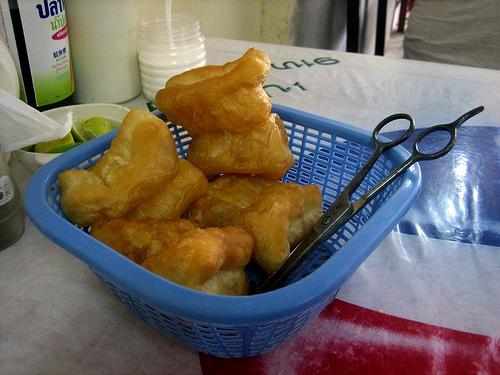Evaluate and describe the quality of the fried doughnuts in the basket. The fried doughnuts in the basket appear to be golden brown and irregular in shape, indicating they may be homemade and freshly cooked. How many distinct objects are visible on the table? There are eight distinct objects on the table: kitchen scissors, blue basket, fried doughnuts, lime wedges in a bowl, table cloth, vanilla extract, cream, and white cloth with green writing. Briefly describe the beverage in the image. There isn't any beverage in the image, but there is a bottle of cream and a bottle of vanilla extract. What are the unique features of the scissors present in the image? The scissors are silver, metal, possess holes in the handle for fingers, and have a screw or bolt on their side, enabling it to function as a pair. Is there any presence of citrus fruit in the image? If so, provide the details of the fruit and where it is placed. Yes, there are some lime wedges in a small white bowl on the table. Mention the colors present on the tablecloth and describe its material. The tablecloth features red, white, and blue colors and is made of plastic material. Determine the color and shape of the symbol on the tablecloth. The symbol on the tablecloth is red, white, and blue in color and is circular in shape. Analyze and explain the interaction between objects in the blue plastic basket. The metal scissors and fried doughnuts are placed together in the blue plastic basket, indicating a possible connection between cutting and serving the food. What type of food is in the blue basket along with the scissors? There are several irregular fried doughnuts in the blue plastic basket. Identify the kitchen utensil located in the basket. A pair of kitchen scissors are situated in the blue plastic basket. Is there any person or animal visible in the image? No, there are no people or animals. List the objects that can be found in the blue plastic basket. kitchen scissors, fried dough According to the text in the image, what is the color of the writing on the white table cloth? green What type of emotion can you infer from the arrangement of objects in the image? No emotions can be inferred from the objects. Do you see the green potted plant placed next to the bowl of lime wedges? A beautiful green plant in a ceramic pot is situated beside the white bowl containing lime wedges. In the context of cooking, discern the main event that the objects in the image suggest. preparing ingredients or serving a meal Identify the event related to food preparation that is represented by the objects in this image. cutting or serving fried dough Where is the open book with a blue bookmark laying on the table underneath the tablecloth? You will find an open book with a story about a magical land, and a vibrant blue bookmark is placed between the pages, partially covered by the tablecloth. Could you point out the steaming cup of coffee located on the table near the pair of scissors? There's a hot cup of coffee beside the kitchen scissors, and you can see the steam rising from it. From the text on the table cloth, determine the colors of the circles and the writing. red, white, blue circles, and green writing No open book or bookmark is mentioned in the image, so this object is not present in the image. No, it's not mentioned in the image. Select the most likely item to be found in a clear glass jar with ridges. Answer:  Analyze if the way the food and scissors are arranged suggests any activities. No activities are evident. What is the color of the basket containing fried dough and scissors? blue Create a sentence describing the scene using food and kitchen items as the main focus. A delicious meal of golden-brown fried dough is served in a blue plastic basket, alongside a bowl of fresh lime wedges and a pair of handy kitchen scissors. Can you find the purple unicorn figurine on the shelf next to the basket? The purple unicorn figurine is on a small wooden shelf to the right of the blue plastic basket. What item can be found at the upper-left corner of the image? a bottle of vanilla extract Provide a high-level description of the items shown in the image. Various food items and utensils, such as fried dough, lime wedges, kitchen scissors, and a blue plastic basket, are arranged on a table with a red, white, and blue tablecloth. Can you identify the piece of chocolate cake that's been half-eaten on a plate beside the fried food? There is a delicious slice of chocolate cake on a round plate, with a few bites already taken from it, located next to the basket of fried food. In the image, ascertain if there are individuals engaged in any activities. No people or activities are present. Identify the contents of the small white bowl. lime wedges Determine the main colors of the table cloth and the writing on it. red, white, blue, and green Composite a sentence that conveys a casual dining experience using the items present in the image. Grab some tasty, golden-brown fried dough from the cool blue basket and spritz it with a squeeze of lime for a laid-back yet flavorful meal. Where is the tiny orange kitten sleeping on the red, white, and blue tablecloth? On the tablecloth, you will notice a small orange kitten curled up and sleeping near the scissors. 